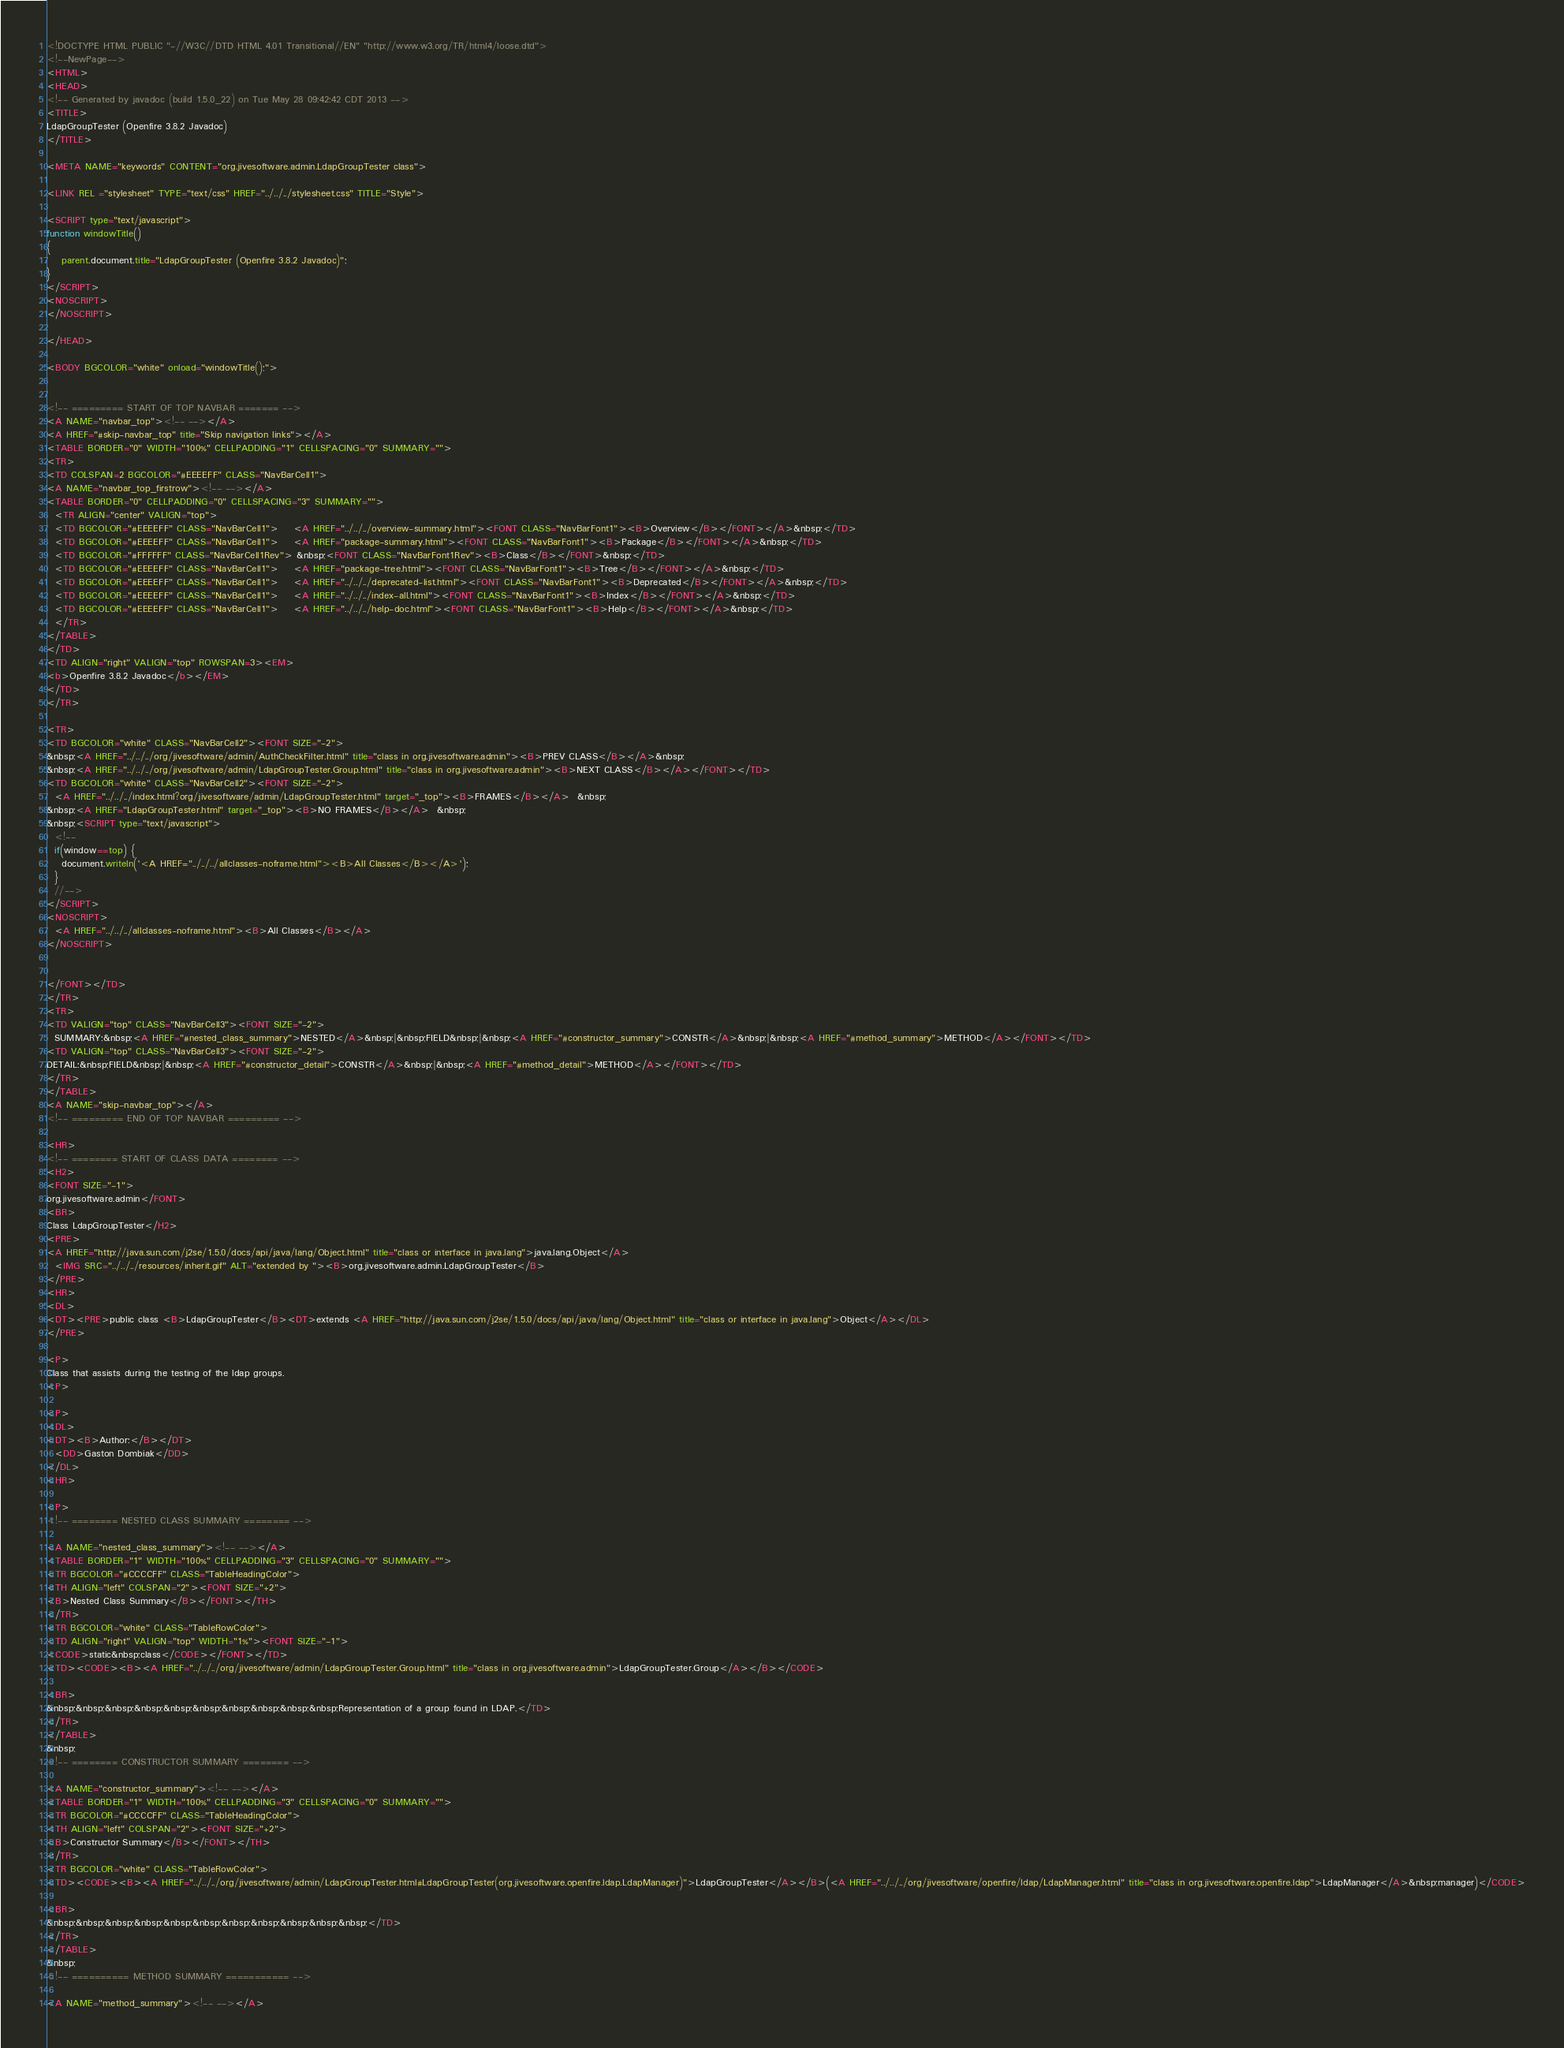Convert code to text. <code><loc_0><loc_0><loc_500><loc_500><_HTML_><!DOCTYPE HTML PUBLIC "-//W3C//DTD HTML 4.01 Transitional//EN" "http://www.w3.org/TR/html4/loose.dtd">
<!--NewPage-->
<HTML>
<HEAD>
<!-- Generated by javadoc (build 1.5.0_22) on Tue May 28 09:42:42 CDT 2013 -->
<TITLE>
LdapGroupTester (Openfire 3.8.2 Javadoc)
</TITLE>

<META NAME="keywords" CONTENT="org.jivesoftware.admin.LdapGroupTester class">

<LINK REL ="stylesheet" TYPE="text/css" HREF="../../../stylesheet.css" TITLE="Style">

<SCRIPT type="text/javascript">
function windowTitle()
{
    parent.document.title="LdapGroupTester (Openfire 3.8.2 Javadoc)";
}
</SCRIPT>
<NOSCRIPT>
</NOSCRIPT>

</HEAD>

<BODY BGCOLOR="white" onload="windowTitle();">


<!-- ========= START OF TOP NAVBAR ======= -->
<A NAME="navbar_top"><!-- --></A>
<A HREF="#skip-navbar_top" title="Skip navigation links"></A>
<TABLE BORDER="0" WIDTH="100%" CELLPADDING="1" CELLSPACING="0" SUMMARY="">
<TR>
<TD COLSPAN=2 BGCOLOR="#EEEEFF" CLASS="NavBarCell1">
<A NAME="navbar_top_firstrow"><!-- --></A>
<TABLE BORDER="0" CELLPADDING="0" CELLSPACING="3" SUMMARY="">
  <TR ALIGN="center" VALIGN="top">
  <TD BGCOLOR="#EEEEFF" CLASS="NavBarCell1">    <A HREF="../../../overview-summary.html"><FONT CLASS="NavBarFont1"><B>Overview</B></FONT></A>&nbsp;</TD>
  <TD BGCOLOR="#EEEEFF" CLASS="NavBarCell1">    <A HREF="package-summary.html"><FONT CLASS="NavBarFont1"><B>Package</B></FONT></A>&nbsp;</TD>
  <TD BGCOLOR="#FFFFFF" CLASS="NavBarCell1Rev"> &nbsp;<FONT CLASS="NavBarFont1Rev"><B>Class</B></FONT>&nbsp;</TD>
  <TD BGCOLOR="#EEEEFF" CLASS="NavBarCell1">    <A HREF="package-tree.html"><FONT CLASS="NavBarFont1"><B>Tree</B></FONT></A>&nbsp;</TD>
  <TD BGCOLOR="#EEEEFF" CLASS="NavBarCell1">    <A HREF="../../../deprecated-list.html"><FONT CLASS="NavBarFont1"><B>Deprecated</B></FONT></A>&nbsp;</TD>
  <TD BGCOLOR="#EEEEFF" CLASS="NavBarCell1">    <A HREF="../../../index-all.html"><FONT CLASS="NavBarFont1"><B>Index</B></FONT></A>&nbsp;</TD>
  <TD BGCOLOR="#EEEEFF" CLASS="NavBarCell1">    <A HREF="../../../help-doc.html"><FONT CLASS="NavBarFont1"><B>Help</B></FONT></A>&nbsp;</TD>
  </TR>
</TABLE>
</TD>
<TD ALIGN="right" VALIGN="top" ROWSPAN=3><EM>
<b>Openfire 3.8.2 Javadoc</b></EM>
</TD>
</TR>

<TR>
<TD BGCOLOR="white" CLASS="NavBarCell2"><FONT SIZE="-2">
&nbsp;<A HREF="../../../org/jivesoftware/admin/AuthCheckFilter.html" title="class in org.jivesoftware.admin"><B>PREV CLASS</B></A>&nbsp;
&nbsp;<A HREF="../../../org/jivesoftware/admin/LdapGroupTester.Group.html" title="class in org.jivesoftware.admin"><B>NEXT CLASS</B></A></FONT></TD>
<TD BGCOLOR="white" CLASS="NavBarCell2"><FONT SIZE="-2">
  <A HREF="../../../index.html?org/jivesoftware/admin/LdapGroupTester.html" target="_top"><B>FRAMES</B></A>  &nbsp;
&nbsp;<A HREF="LdapGroupTester.html" target="_top"><B>NO FRAMES</B></A>  &nbsp;
&nbsp;<SCRIPT type="text/javascript">
  <!--
  if(window==top) {
    document.writeln('<A HREF="../../../allclasses-noframe.html"><B>All Classes</B></A>');
  }
  //-->
</SCRIPT>
<NOSCRIPT>
  <A HREF="../../../allclasses-noframe.html"><B>All Classes</B></A>
</NOSCRIPT>


</FONT></TD>
</TR>
<TR>
<TD VALIGN="top" CLASS="NavBarCell3"><FONT SIZE="-2">
  SUMMARY:&nbsp;<A HREF="#nested_class_summary">NESTED</A>&nbsp;|&nbsp;FIELD&nbsp;|&nbsp;<A HREF="#constructor_summary">CONSTR</A>&nbsp;|&nbsp;<A HREF="#method_summary">METHOD</A></FONT></TD>
<TD VALIGN="top" CLASS="NavBarCell3"><FONT SIZE="-2">
DETAIL:&nbsp;FIELD&nbsp;|&nbsp;<A HREF="#constructor_detail">CONSTR</A>&nbsp;|&nbsp;<A HREF="#method_detail">METHOD</A></FONT></TD>
</TR>
</TABLE>
<A NAME="skip-navbar_top"></A>
<!-- ========= END OF TOP NAVBAR ========= -->

<HR>
<!-- ======== START OF CLASS DATA ======== -->
<H2>
<FONT SIZE="-1">
org.jivesoftware.admin</FONT>
<BR>
Class LdapGroupTester</H2>
<PRE>
<A HREF="http://java.sun.com/j2se/1.5.0/docs/api/java/lang/Object.html" title="class or interface in java.lang">java.lang.Object</A>
  <IMG SRC="../../../resources/inherit.gif" ALT="extended by "><B>org.jivesoftware.admin.LdapGroupTester</B>
</PRE>
<HR>
<DL>
<DT><PRE>public class <B>LdapGroupTester</B><DT>extends <A HREF="http://java.sun.com/j2se/1.5.0/docs/api/java/lang/Object.html" title="class or interface in java.lang">Object</A></DL>
</PRE>

<P>
Class that assists during the testing of the ldap groups.
<P>

<P>
<DL>
<DT><B>Author:</B></DT>
  <DD>Gaston Dombiak</DD>
</DL>
<HR>

<P>
<!-- ======== NESTED CLASS SUMMARY ======== -->

<A NAME="nested_class_summary"><!-- --></A>
<TABLE BORDER="1" WIDTH="100%" CELLPADDING="3" CELLSPACING="0" SUMMARY="">
<TR BGCOLOR="#CCCCFF" CLASS="TableHeadingColor">
<TH ALIGN="left" COLSPAN="2"><FONT SIZE="+2">
<B>Nested Class Summary</B></FONT></TH>
</TR>
<TR BGCOLOR="white" CLASS="TableRowColor">
<TD ALIGN="right" VALIGN="top" WIDTH="1%"><FONT SIZE="-1">
<CODE>static&nbsp;class</CODE></FONT></TD>
<TD><CODE><B><A HREF="../../../org/jivesoftware/admin/LdapGroupTester.Group.html" title="class in org.jivesoftware.admin">LdapGroupTester.Group</A></B></CODE>

<BR>
&nbsp;&nbsp;&nbsp;&nbsp;&nbsp;&nbsp;&nbsp;&nbsp;&nbsp;&nbsp;Representation of a group found in LDAP.</TD>
</TR>
</TABLE>
&nbsp;
<!-- ======== CONSTRUCTOR SUMMARY ======== -->

<A NAME="constructor_summary"><!-- --></A>
<TABLE BORDER="1" WIDTH="100%" CELLPADDING="3" CELLSPACING="0" SUMMARY="">
<TR BGCOLOR="#CCCCFF" CLASS="TableHeadingColor">
<TH ALIGN="left" COLSPAN="2"><FONT SIZE="+2">
<B>Constructor Summary</B></FONT></TH>
</TR>
<TR BGCOLOR="white" CLASS="TableRowColor">
<TD><CODE><B><A HREF="../../../org/jivesoftware/admin/LdapGroupTester.html#LdapGroupTester(org.jivesoftware.openfire.ldap.LdapManager)">LdapGroupTester</A></B>(<A HREF="../../../org/jivesoftware/openfire/ldap/LdapManager.html" title="class in org.jivesoftware.openfire.ldap">LdapManager</A>&nbsp;manager)</CODE>

<BR>
&nbsp;&nbsp;&nbsp;&nbsp;&nbsp;&nbsp;&nbsp;&nbsp;&nbsp;&nbsp;&nbsp;</TD>
</TR>
</TABLE>
&nbsp;
<!-- ========== METHOD SUMMARY =========== -->

<A NAME="method_summary"><!-- --></A></code> 